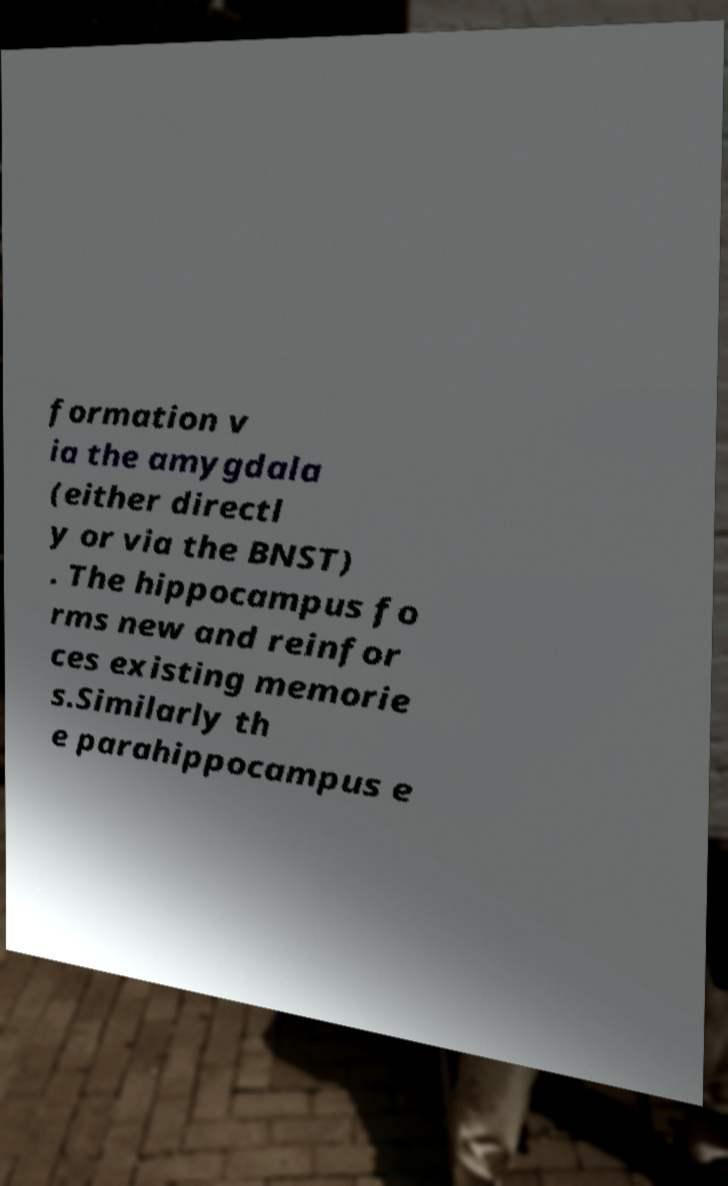Please read and relay the text visible in this image. What does it say? formation v ia the amygdala (either directl y or via the BNST) . The hippocampus fo rms new and reinfor ces existing memorie s.Similarly th e parahippocampus e 